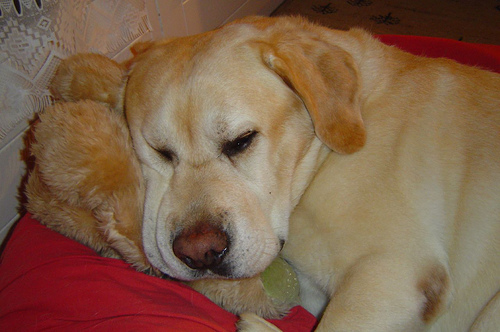How many dogs are there? 1 